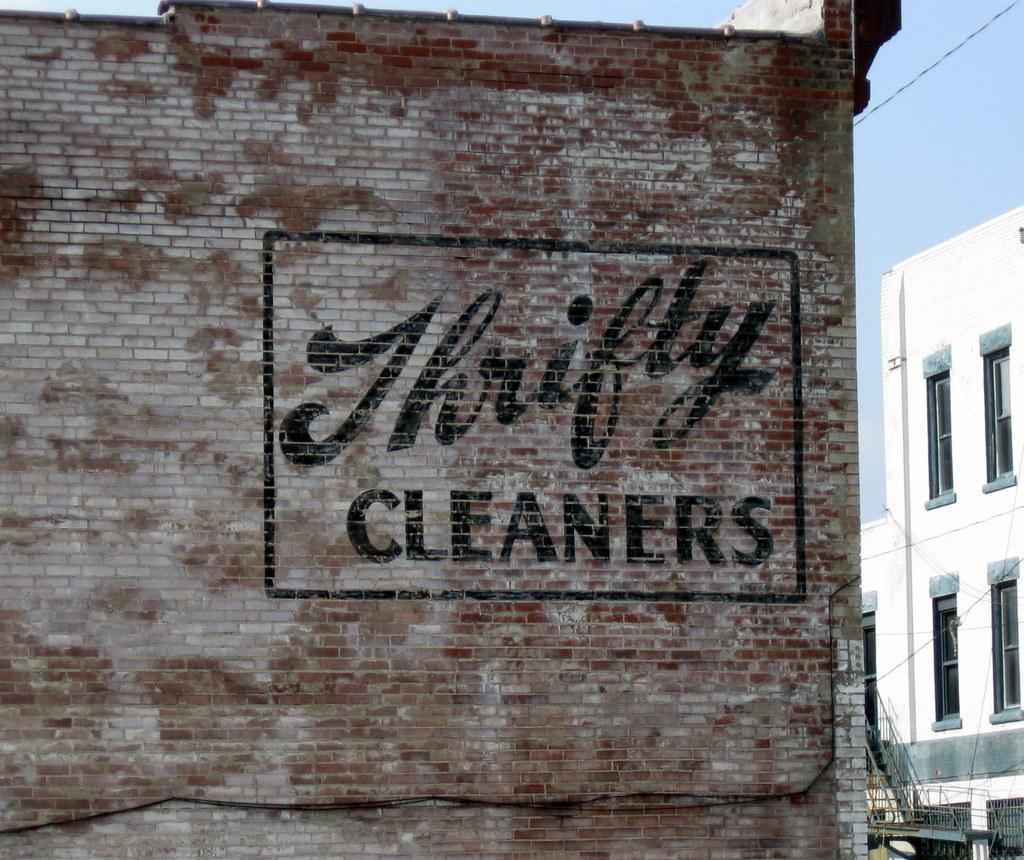What type of structures can be seen in the image? There are buildings in the image. What part of the natural environment is visible in the image? The sky is visible in the image. What type of seed can be seen growing in the image? There is no seed or plant growth visible in the image; it primarily features buildings and the sky. 